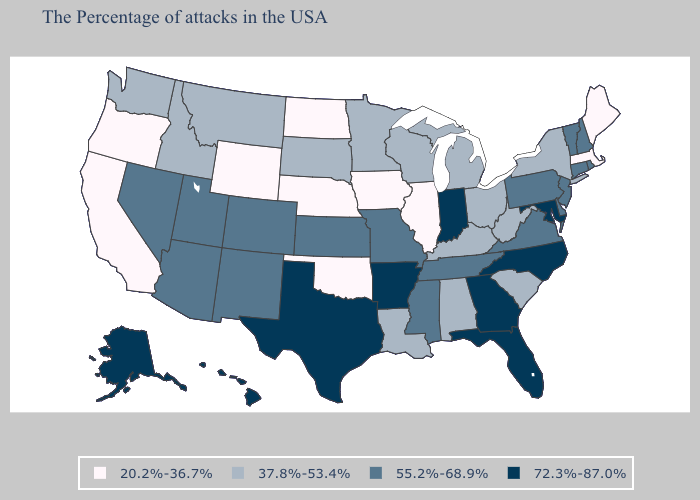Does Ohio have the same value as Nebraska?
Write a very short answer. No. Does Delaware have the highest value in the South?
Keep it brief. No. Does the first symbol in the legend represent the smallest category?
Be succinct. Yes. Does the first symbol in the legend represent the smallest category?
Short answer required. Yes. What is the value of California?
Write a very short answer. 20.2%-36.7%. Name the states that have a value in the range 55.2%-68.9%?
Quick response, please. Rhode Island, New Hampshire, Vermont, Connecticut, New Jersey, Delaware, Pennsylvania, Virginia, Tennessee, Mississippi, Missouri, Kansas, Colorado, New Mexico, Utah, Arizona, Nevada. Does Illinois have a lower value than Mississippi?
Be succinct. Yes. Does Arkansas have the same value as Texas?
Write a very short answer. Yes. What is the lowest value in the USA?
Give a very brief answer. 20.2%-36.7%. What is the lowest value in states that border Maine?
Be succinct. 55.2%-68.9%. Does Alaska have the highest value in the USA?
Give a very brief answer. Yes. Name the states that have a value in the range 55.2%-68.9%?
Answer briefly. Rhode Island, New Hampshire, Vermont, Connecticut, New Jersey, Delaware, Pennsylvania, Virginia, Tennessee, Mississippi, Missouri, Kansas, Colorado, New Mexico, Utah, Arizona, Nevada. Among the states that border Montana , which have the lowest value?
Concise answer only. North Dakota, Wyoming. Among the states that border North Carolina , does Georgia have the highest value?
Answer briefly. Yes. Does Illinois have a lower value than North Dakota?
Keep it brief. No. 